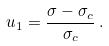<formula> <loc_0><loc_0><loc_500><loc_500>u _ { 1 } = \frac { \sigma - \sigma _ { c } } { \sigma _ { c } } \, .</formula> 